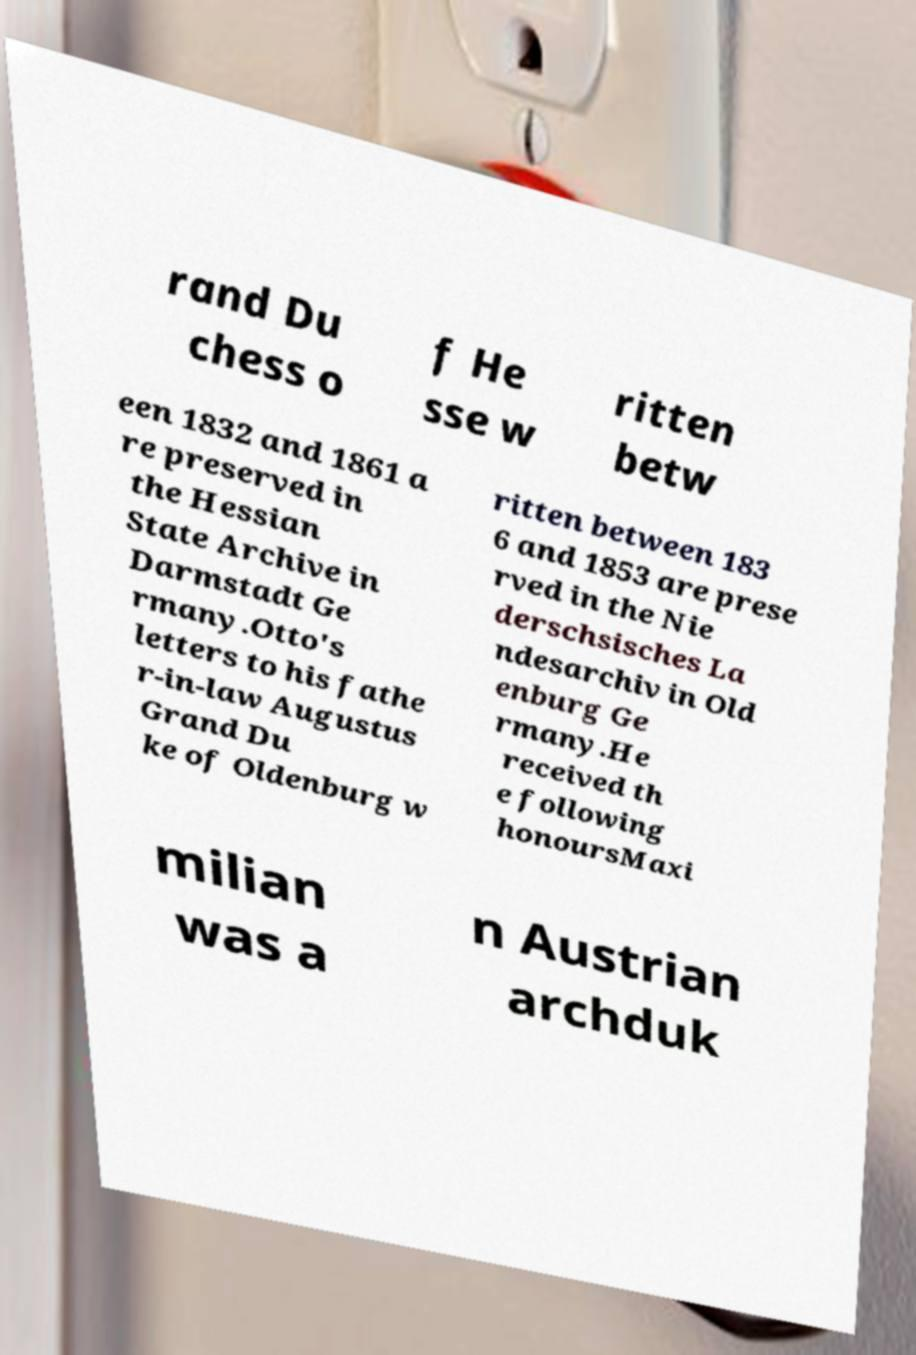What messages or text are displayed in this image? I need them in a readable, typed format. rand Du chess o f He sse w ritten betw een 1832 and 1861 a re preserved in the Hessian State Archive in Darmstadt Ge rmany.Otto's letters to his fathe r-in-law Augustus Grand Du ke of Oldenburg w ritten between 183 6 and 1853 are prese rved in the Nie derschsisches La ndesarchiv in Old enburg Ge rmany.He received th e following honoursMaxi milian was a n Austrian archduk 